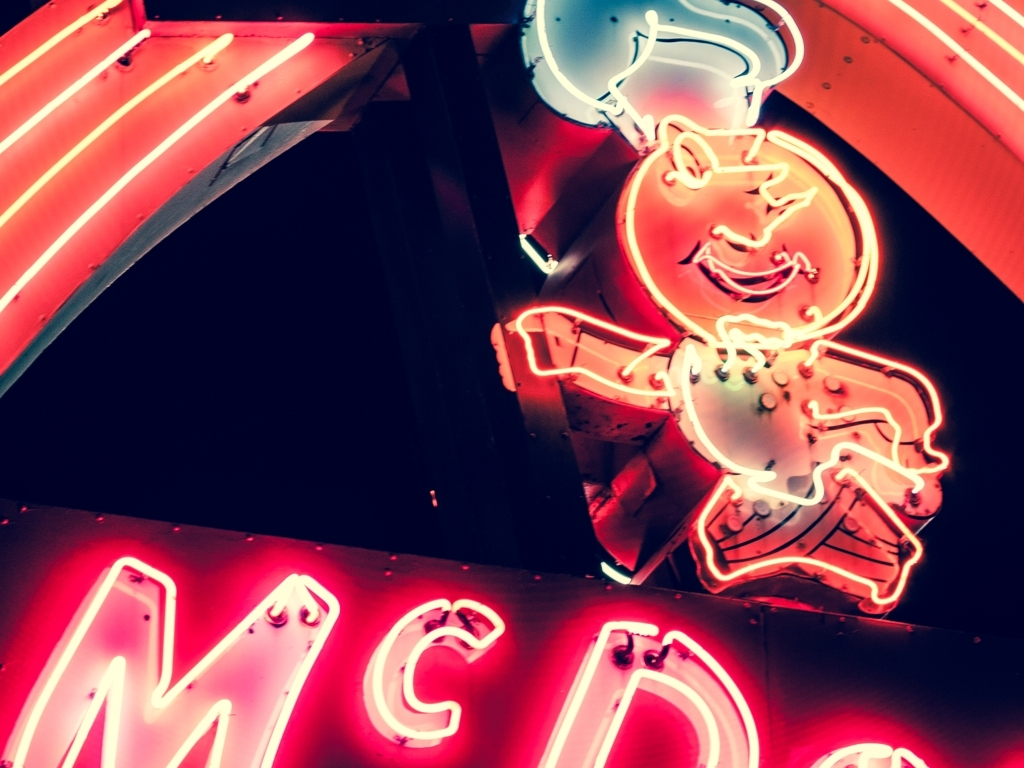Is the quality of this image mediocre? The term 'mediocre' is quite subjective when discussing image quality. In this particular case, the creative intent seems to be to evoke a vintage, nostalgic aesthetic with the neon lights and the branding. The slightly overexposed lighting and retro feel could be intentional to convey a specific mood or atmosphere. Therefore, whether the quality is deemed mediocre might depend on the viewer's expectations and the context in which the image is being used. 